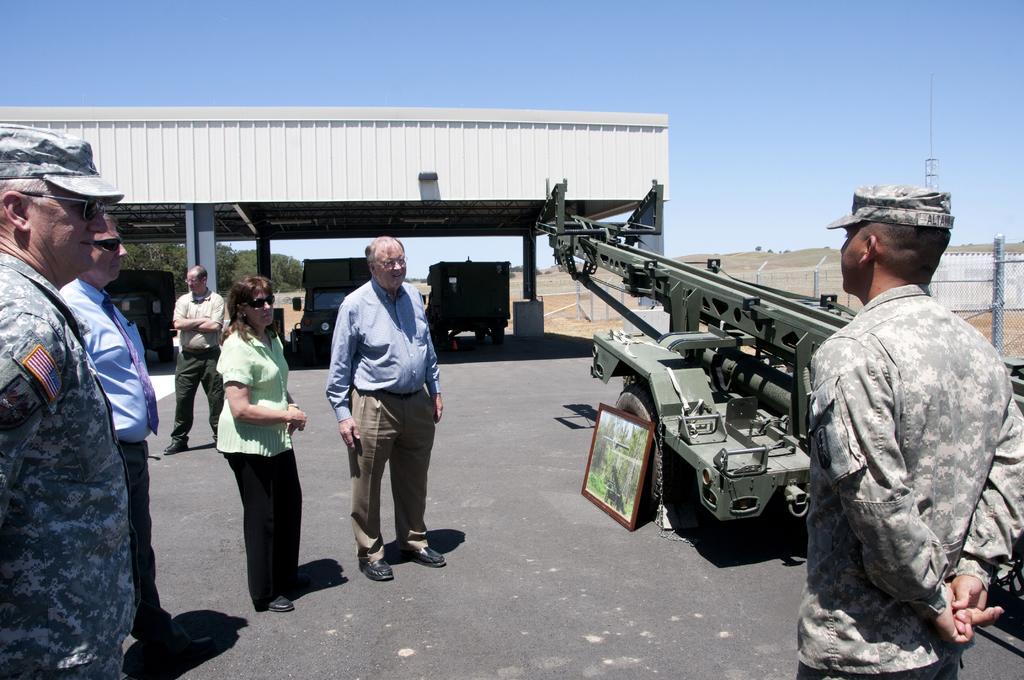How would you summarize this image in a sentence or two? In this image we can see few people. Some are wearing goggles and cap. On the right side there is a crane. Near to the crane there is a frame. In the back there is a shed. Below the shed there are few vehicles. In the background there is sky. Also there are railings on the right side. 